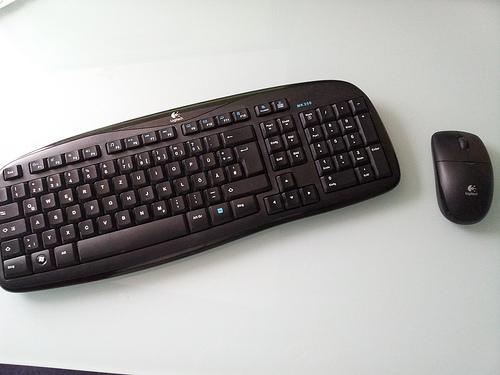Question: how many cords are visible?
Choices:
A. None.
B. About twelve.
C. Three.
D. Five.
Answer with the letter. Answer: A Question: what side of the keyboard is the mouse on?
Choices:
A. To the left.
B. In front of.
C. The right.
D. Behind.
Answer with the letter. Answer: C Question: how many arrows are on the keyboard?
Choices:
A. Four.
B. Eight.
C. Twelve.
D. Two.
Answer with the letter. Answer: A Question: what brand are these?
Choices:
A. Adidas.
B. Dell.
C. Logitech.
D. Apple.
Answer with the letter. Answer: C 